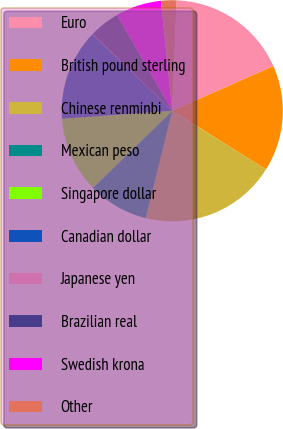<chart> <loc_0><loc_0><loc_500><loc_500><pie_chart><fcel>Euro<fcel>British pound sterling<fcel>Chinese renminbi<fcel>Mexican peso<fcel>Singapore dollar<fcel>Canadian dollar<fcel>Japanese yen<fcel>Brazilian real<fcel>Swedish krona<fcel>Other<nl><fcel>17.74%<fcel>15.53%<fcel>19.95%<fcel>8.89%<fcel>11.11%<fcel>13.32%<fcel>0.05%<fcel>4.47%<fcel>6.68%<fcel>2.26%<nl></chart> 